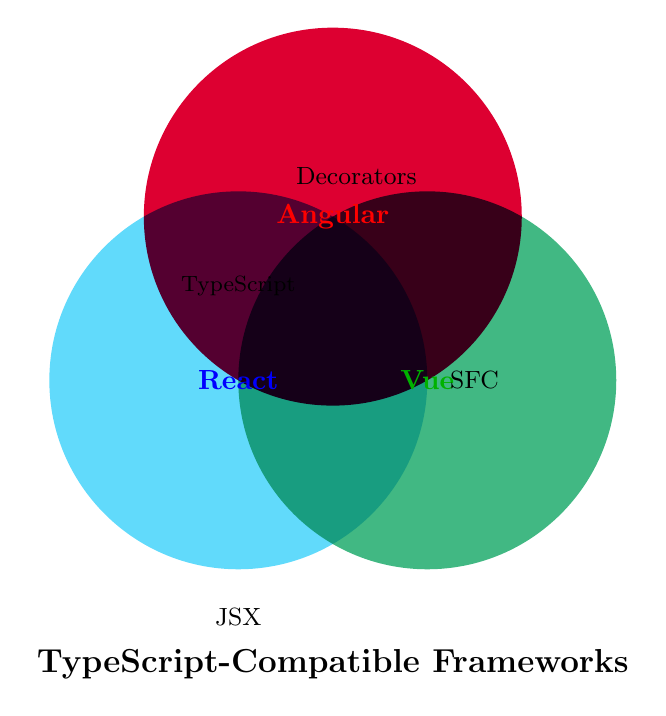What is the title of the figure? The title of the figure is located at the bottom and reads "\textbf{TypeScript-Compatible Frameworks}".
Answer: TypeScript-Compatible Frameworks Which framework is represented by the blue circle? The blue-colored circle is labeled "React".
Answer: React Which frameworks have a dedicated label for JSX? JSX is labeled near the blue-colored circle for React.
Answer: React How many frameworks are compatible with TypeScript? All frameworks (React, Angular, Vue) intersect with the central area labeled "TypeScript".
Answer: Three (React, Angular, Vue) Which framework is represented by the green circle? The green-colored circle is labeled "Vue".
Answer: Vue Which attribute is exclusive to Angular? The attribute labeled "Decorators" is positioned close to the red-colored circle representing Angular.
Answer: Decorators What label lies in the intersection of all three circles? The central label where all circles intersect reads "TypeScript".
Answer: TypeScript Which frameworks do not support Single-File Components (SFC)? The attribute labeled "SFC" is positioned near the green circle (Vue), meaning React and Angular do not support it.
Answer: React and Angular Which framework does not intersect with Vue? The blue circle (React) does not overlap with the green circle (Vue).
Answer: React Is there any attribute exclusive to React? The attribute “JSX” is labeled near the blue circle for React.
Answer: JSX 